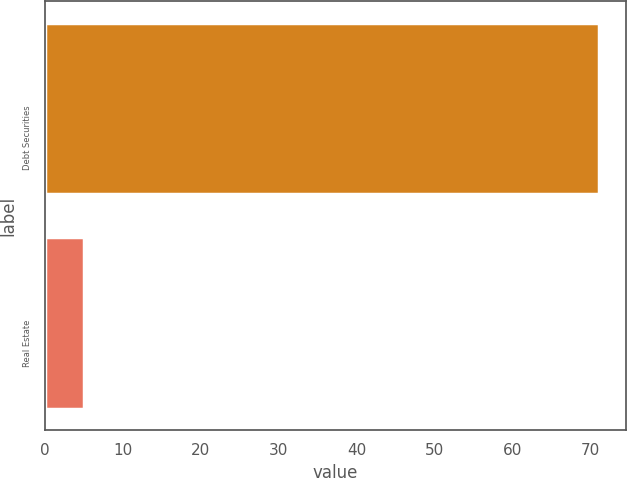<chart> <loc_0><loc_0><loc_500><loc_500><bar_chart><fcel>Debt Securities<fcel>Real Estate<nl><fcel>71<fcel>5<nl></chart> 